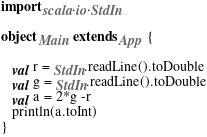Convert code to text. <code><loc_0><loc_0><loc_500><loc_500><_Scala_>import scala.io.StdIn

object Main extends App {
  
   val r = StdIn.readLine().toDouble
   val g = StdIn.readLine().toDouble
   val a = 2*g -r
   println(a.toInt)
}
</code> 